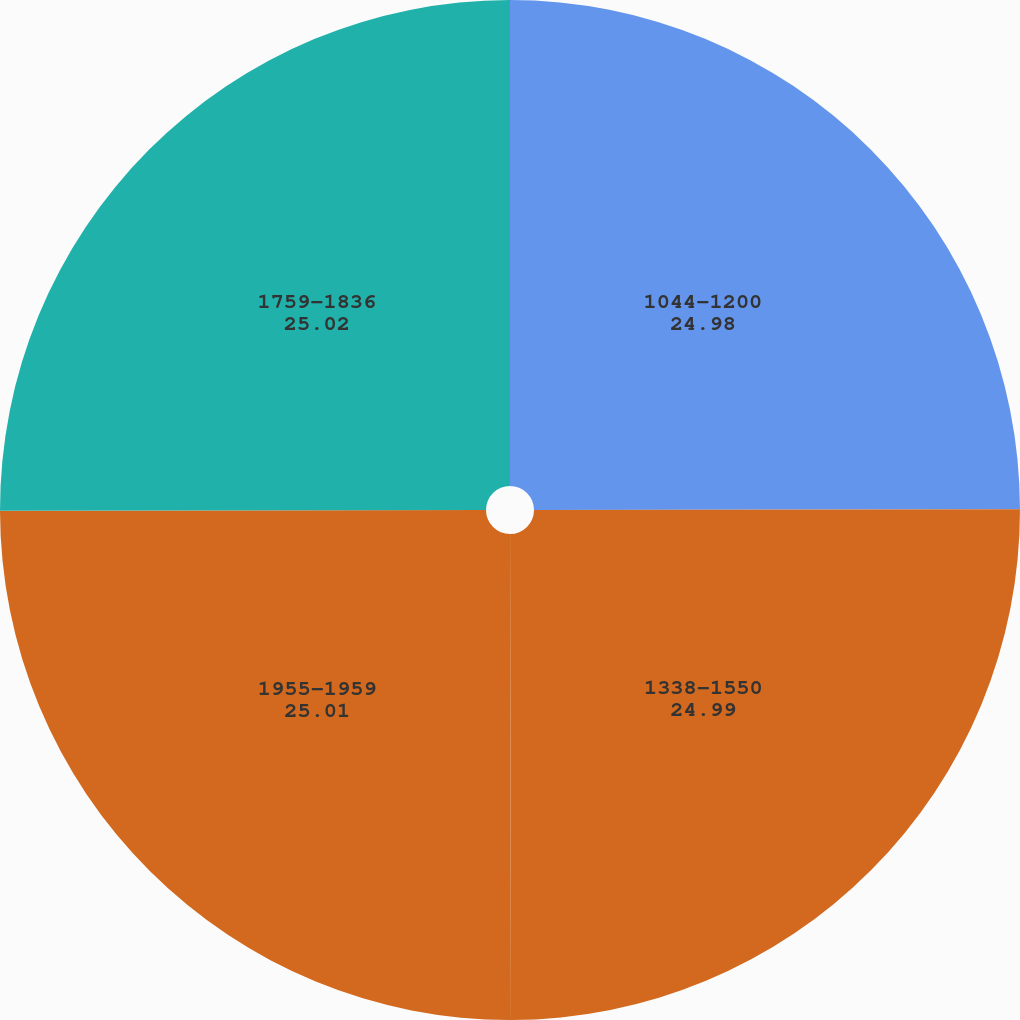<chart> <loc_0><loc_0><loc_500><loc_500><pie_chart><fcel>1044-1200<fcel>1338-1550<fcel>1955-1959<fcel>1759-1836<nl><fcel>24.98%<fcel>24.99%<fcel>25.01%<fcel>25.02%<nl></chart> 